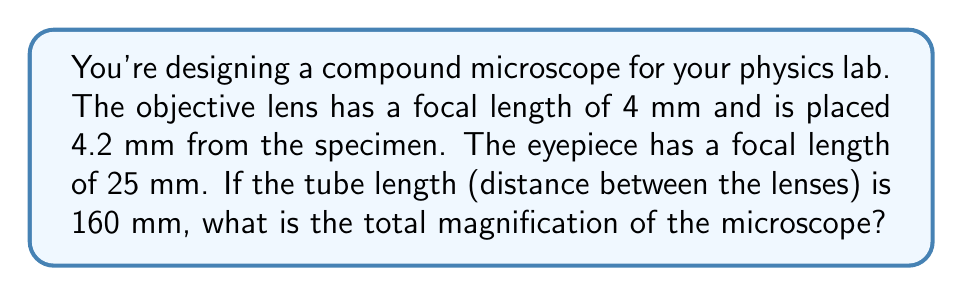Provide a solution to this math problem. Let's approach this step-by-step:

1) First, we need to calculate the magnification of the objective lens ($M_o$). The formula for this is:

   $M_o = \frac{v_o}{f_o}$

   Where $v_o$ is the image distance from the objective lens and $f_o$ is its focal length.

2) To find $v_o$, we can use the thin lens equation:

   $\frac{1}{f_o} = \frac{1}{u_o} + \frac{1}{v_o}$

   Where $u_o$ is the object distance (4.2 mm) and $f_o$ is 4 mm.

3) Substituting the values:

   $\frac{1}{4} = \frac{1}{4.2} + \frac{1}{v_o}$

4) Solving for $v_o$:

   $v_o = 84$ mm

5) Now we can calculate $M_o$:

   $M_o = \frac{84}{4} = 21$

6) For the eyepiece, the object is the image formed by the objective lens. Its distance from the eyepiece is:

   $u_e = 160 - 84 = 76$ mm

7) The magnification of the eyepiece ($M_e$) is:

   $M_e = \frac{25}{25-76} = -3.04$

8) The total magnification ($M_t$) is the product of $M_o$ and $M_e$:

   $M_t = M_o \times M_e = 21 \times (-3.04) = -63.84$

The negative sign indicates an inverted image, but we're typically concerned with the absolute value for magnification.
Answer: 63.84x 